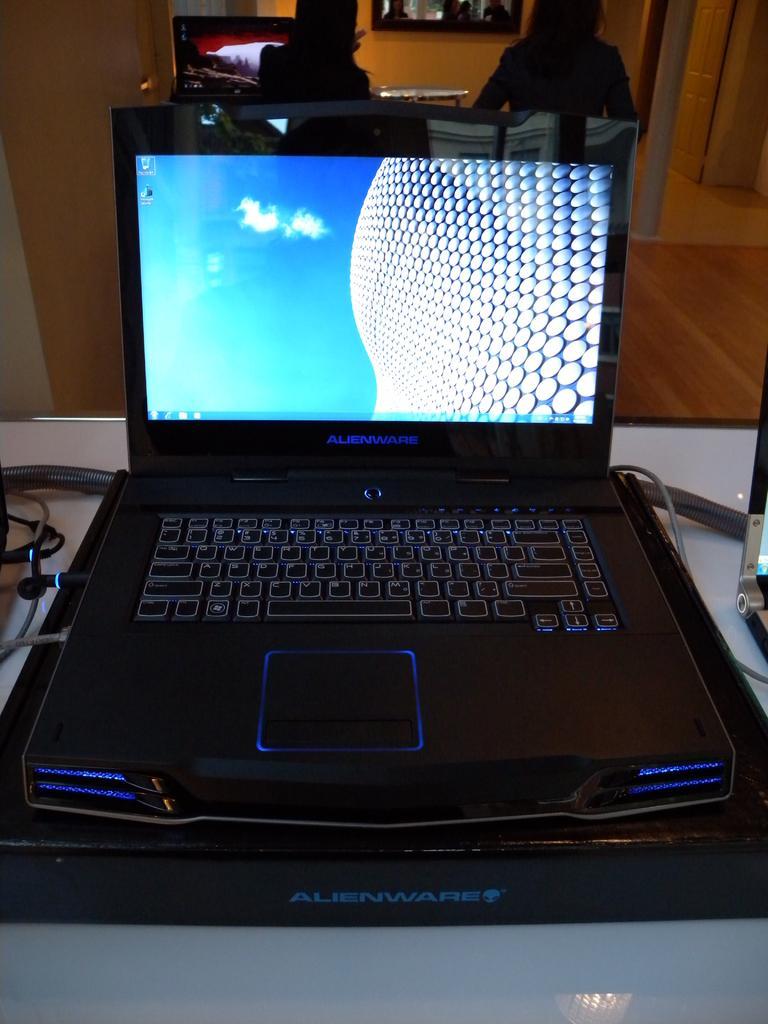<image>
Summarize the visual content of the image. An Alienware brand computer is opened up to the home screen. 